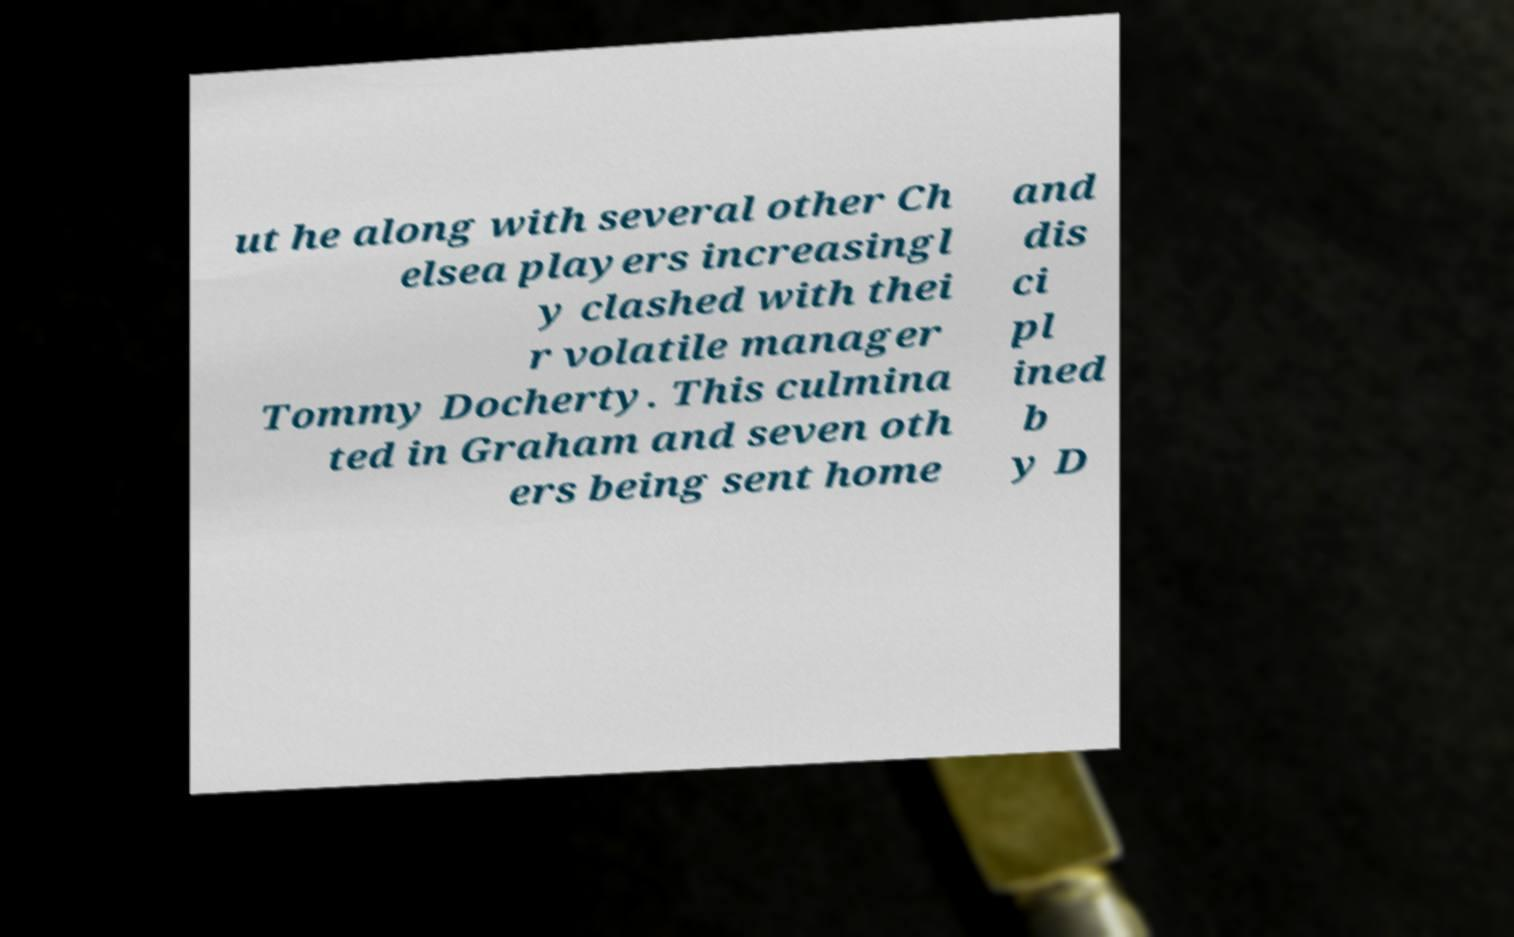Could you extract and type out the text from this image? ut he along with several other Ch elsea players increasingl y clashed with thei r volatile manager Tommy Docherty. This culmina ted in Graham and seven oth ers being sent home and dis ci pl ined b y D 